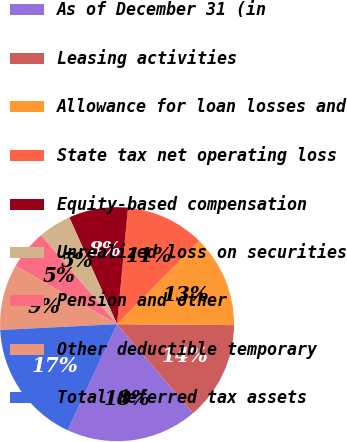<chart> <loc_0><loc_0><loc_500><loc_500><pie_chart><fcel>As of December 31 (in<fcel>Leasing activities<fcel>Allowance for loan losses and<fcel>State tax net operating loss<fcel>Equity-based compensation<fcel>Unrealized loss on securities<fcel>Pension and other<fcel>Other deductible temporary<fcel>Total deferred tax assets<nl><fcel>18.18%<fcel>13.63%<fcel>12.73%<fcel>10.91%<fcel>8.18%<fcel>4.55%<fcel>5.46%<fcel>9.09%<fcel>17.27%<nl></chart> 